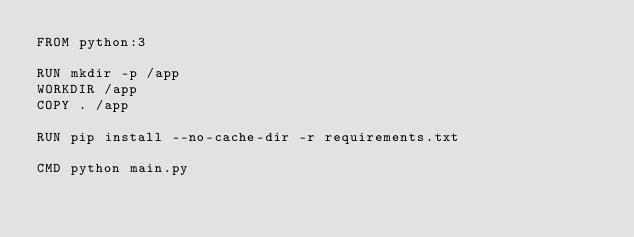Convert code to text. <code><loc_0><loc_0><loc_500><loc_500><_Dockerfile_>FROM python:3

RUN mkdir -p /app
WORKDIR /app
COPY . /app

RUN pip install --no-cache-dir -r requirements.txt

CMD python main.py
</code> 